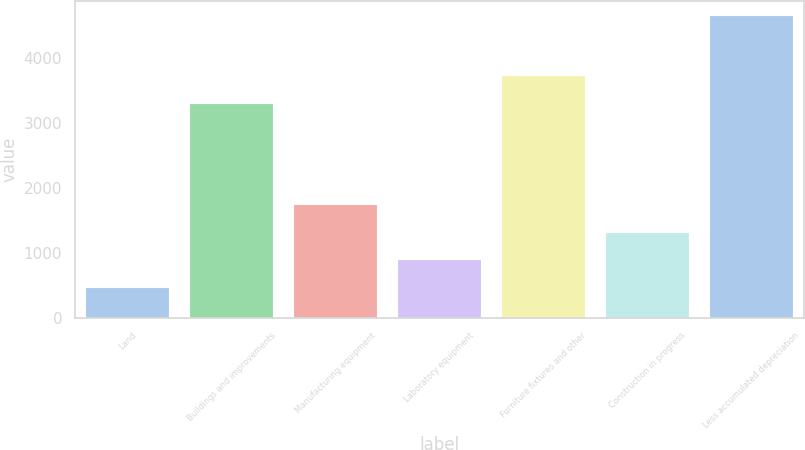Convert chart. <chart><loc_0><loc_0><loc_500><loc_500><bar_chart><fcel>Land<fcel>Buildings and improvements<fcel>Manufacturing equipment<fcel>Laboratory equipment<fcel>Furniture fixtures and other<fcel>Construction in progress<fcel>Less accumulated depreciation<nl><fcel>450<fcel>3293<fcel>1729.6<fcel>892<fcel>3711.8<fcel>1310.8<fcel>4638<nl></chart> 